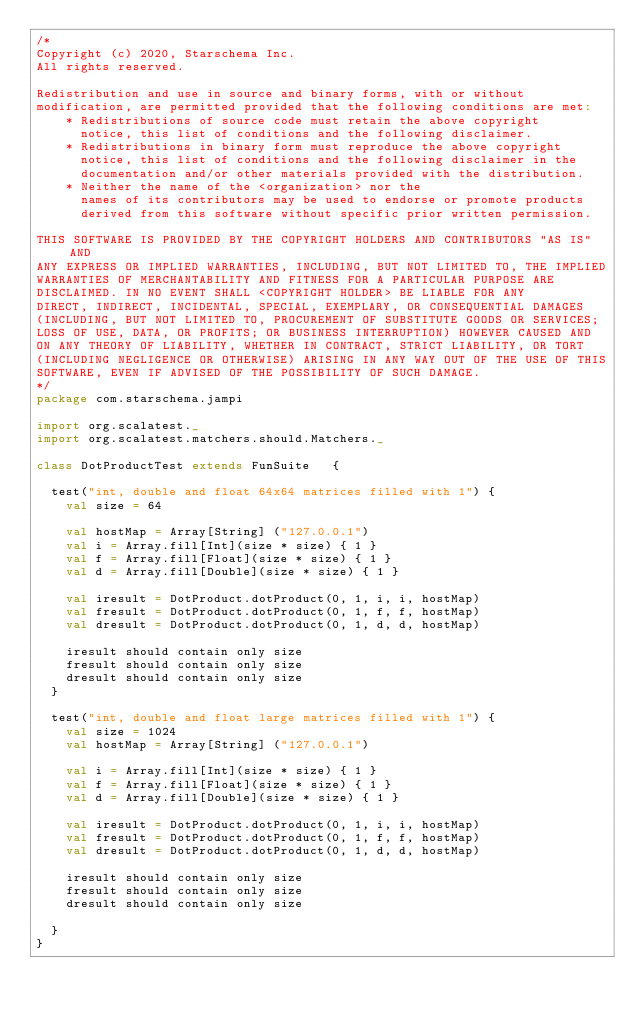<code> <loc_0><loc_0><loc_500><loc_500><_Scala_>/*
Copyright (c) 2020, Starschema Inc.
All rights reserved.

Redistribution and use in source and binary forms, with or without
modification, are permitted provided that the following conditions are met:
    * Redistributions of source code must retain the above copyright
      notice, this list of conditions and the following disclaimer.
    * Redistributions in binary form must reproduce the above copyright
      notice, this list of conditions and the following disclaimer in the
      documentation and/or other materials provided with the distribution.
    * Neither the name of the <organization> nor the
      names of its contributors may be used to endorse or promote products
      derived from this software without specific prior written permission.

THIS SOFTWARE IS PROVIDED BY THE COPYRIGHT HOLDERS AND CONTRIBUTORS "AS IS" AND
ANY EXPRESS OR IMPLIED WARRANTIES, INCLUDING, BUT NOT LIMITED TO, THE IMPLIED
WARRANTIES OF MERCHANTABILITY AND FITNESS FOR A PARTICULAR PURPOSE ARE
DISCLAIMED. IN NO EVENT SHALL <COPYRIGHT HOLDER> BE LIABLE FOR ANY
DIRECT, INDIRECT, INCIDENTAL, SPECIAL, EXEMPLARY, OR CONSEQUENTIAL DAMAGES
(INCLUDING, BUT NOT LIMITED TO, PROCUREMENT OF SUBSTITUTE GOODS OR SERVICES;
LOSS OF USE, DATA, OR PROFITS; OR BUSINESS INTERRUPTION) HOWEVER CAUSED AND
ON ANY THEORY OF LIABILITY, WHETHER IN CONTRACT, STRICT LIABILITY, OR TORT
(INCLUDING NEGLIGENCE OR OTHERWISE) ARISING IN ANY WAY OUT OF THE USE OF THIS
SOFTWARE, EVEN IF ADVISED OF THE POSSIBILITY OF SUCH DAMAGE.
*/
package com.starschema.jampi

import org.scalatest._
import org.scalatest.matchers.should.Matchers._

class DotProductTest extends FunSuite   {

  test("int, double and float 64x64 matrices filled with 1") {
    val size = 64

    val hostMap = Array[String] ("127.0.0.1")
    val i = Array.fill[Int](size * size) { 1 }
    val f = Array.fill[Float](size * size) { 1 }
    val d = Array.fill[Double](size * size) { 1 }

    val iresult = DotProduct.dotProduct(0, 1, i, i, hostMap)
    val fresult = DotProduct.dotProduct(0, 1, f, f, hostMap)
    val dresult = DotProduct.dotProduct(0, 1, d, d, hostMap)

    iresult should contain only size
    fresult should contain only size
    dresult should contain only size
  }

  test("int, double and float large matrices filled with 1") {
    val size = 1024
    val hostMap = Array[String] ("127.0.0.1")

    val i = Array.fill[Int](size * size) { 1 }
    val f = Array.fill[Float](size * size) { 1 }
    val d = Array.fill[Double](size * size) { 1 }

    val iresult = DotProduct.dotProduct(0, 1, i, i, hostMap)
    val fresult = DotProduct.dotProduct(0, 1, f, f, hostMap)
    val dresult = DotProduct.dotProduct(0, 1, d, d, hostMap)

    iresult should contain only size
    fresult should contain only size
    dresult should contain only size

  }
}
</code> 